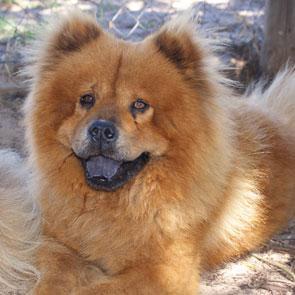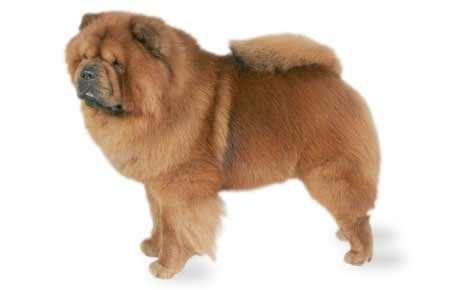The first image is the image on the left, the second image is the image on the right. Considering the images on both sides, is "There are two dogs in the right image." valid? Answer yes or no. No. The first image is the image on the left, the second image is the image on the right. Given the left and right images, does the statement "Each image contains the same number of dogs, the left image includes a dog with its blue tongue out, and at least one image features a dog in a standing pose." hold true? Answer yes or no. Yes. 